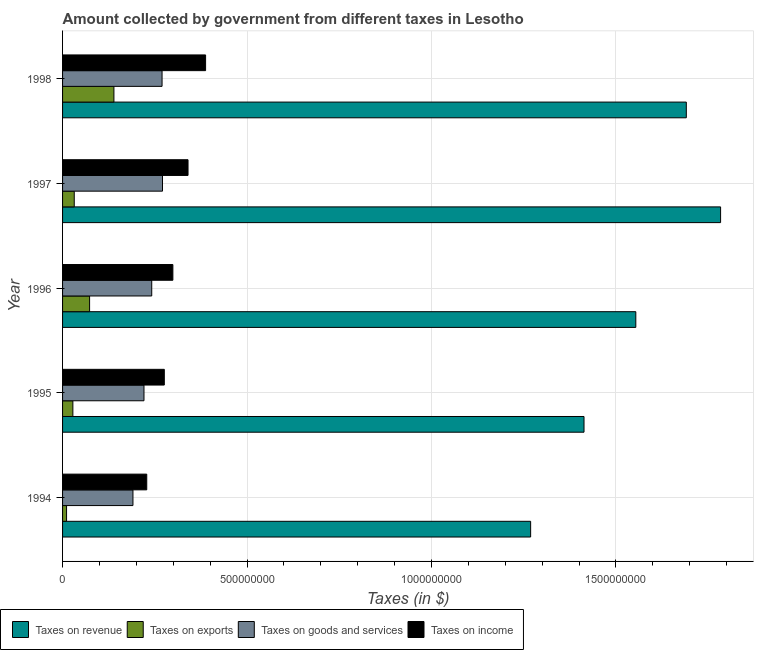How many bars are there on the 2nd tick from the bottom?
Provide a short and direct response. 4. What is the amount collected as tax on revenue in 1995?
Offer a very short reply. 1.41e+09. Across all years, what is the maximum amount collected as tax on income?
Offer a terse response. 3.88e+08. Across all years, what is the minimum amount collected as tax on goods?
Give a very brief answer. 1.91e+08. What is the total amount collected as tax on exports in the graph?
Your answer should be very brief. 2.83e+08. What is the difference between the amount collected as tax on goods in 1994 and that in 1997?
Your answer should be compact. -8.01e+07. What is the difference between the amount collected as tax on exports in 1994 and the amount collected as tax on income in 1995?
Keep it short and to the point. -2.65e+08. What is the average amount collected as tax on income per year?
Offer a very short reply. 3.06e+08. In the year 1996, what is the difference between the amount collected as tax on goods and amount collected as tax on revenue?
Your answer should be compact. -1.31e+09. In how many years, is the amount collected as tax on exports greater than 600000000 $?
Your response must be concise. 0. What is the ratio of the amount collected as tax on income in 1997 to that in 1998?
Your answer should be compact. 0.88. Is the difference between the amount collected as tax on revenue in 1994 and 1996 greater than the difference between the amount collected as tax on goods in 1994 and 1996?
Your response must be concise. No. What is the difference between the highest and the second highest amount collected as tax on goods?
Provide a succinct answer. 1.20e+06. What is the difference between the highest and the lowest amount collected as tax on exports?
Your answer should be very brief. 1.28e+08. Is it the case that in every year, the sum of the amount collected as tax on exports and amount collected as tax on income is greater than the sum of amount collected as tax on goods and amount collected as tax on revenue?
Keep it short and to the point. No. What does the 4th bar from the top in 1997 represents?
Your response must be concise. Taxes on revenue. What does the 3rd bar from the bottom in 1997 represents?
Your answer should be compact. Taxes on goods and services. Is it the case that in every year, the sum of the amount collected as tax on revenue and amount collected as tax on exports is greater than the amount collected as tax on goods?
Provide a succinct answer. Yes. Are all the bars in the graph horizontal?
Offer a very short reply. Yes. What is the difference between two consecutive major ticks on the X-axis?
Your response must be concise. 5.00e+08. Are the values on the major ticks of X-axis written in scientific E-notation?
Provide a short and direct response. No. Does the graph contain any zero values?
Keep it short and to the point. No. Where does the legend appear in the graph?
Your answer should be very brief. Bottom left. How are the legend labels stacked?
Your response must be concise. Horizontal. What is the title of the graph?
Provide a succinct answer. Amount collected by government from different taxes in Lesotho. What is the label or title of the X-axis?
Provide a succinct answer. Taxes (in $). What is the Taxes (in $) in Taxes on revenue in 1994?
Provide a succinct answer. 1.27e+09. What is the Taxes (in $) of Taxes on exports in 1994?
Your answer should be compact. 1.08e+07. What is the Taxes (in $) in Taxes on goods and services in 1994?
Offer a terse response. 1.91e+08. What is the Taxes (in $) in Taxes on income in 1994?
Your answer should be compact. 2.28e+08. What is the Taxes (in $) in Taxes on revenue in 1995?
Your response must be concise. 1.41e+09. What is the Taxes (in $) in Taxes on exports in 1995?
Offer a terse response. 2.79e+07. What is the Taxes (in $) in Taxes on goods and services in 1995?
Offer a very short reply. 2.21e+08. What is the Taxes (in $) in Taxes on income in 1995?
Keep it short and to the point. 2.76e+08. What is the Taxes (in $) in Taxes on revenue in 1996?
Offer a terse response. 1.55e+09. What is the Taxes (in $) of Taxes on exports in 1996?
Give a very brief answer. 7.33e+07. What is the Taxes (in $) in Taxes on goods and services in 1996?
Offer a terse response. 2.42e+08. What is the Taxes (in $) of Taxes on income in 1996?
Your answer should be compact. 2.99e+08. What is the Taxes (in $) of Taxes on revenue in 1997?
Keep it short and to the point. 1.78e+09. What is the Taxes (in $) in Taxes on exports in 1997?
Provide a succinct answer. 3.17e+07. What is the Taxes (in $) in Taxes on goods and services in 1997?
Your response must be concise. 2.71e+08. What is the Taxes (in $) of Taxes on income in 1997?
Offer a very short reply. 3.40e+08. What is the Taxes (in $) of Taxes on revenue in 1998?
Your answer should be very brief. 1.69e+09. What is the Taxes (in $) in Taxes on exports in 1998?
Offer a very short reply. 1.39e+08. What is the Taxes (in $) of Taxes on goods and services in 1998?
Your answer should be very brief. 2.70e+08. What is the Taxes (in $) in Taxes on income in 1998?
Ensure brevity in your answer.  3.88e+08. Across all years, what is the maximum Taxes (in $) of Taxes on revenue?
Ensure brevity in your answer.  1.78e+09. Across all years, what is the maximum Taxes (in $) in Taxes on exports?
Keep it short and to the point. 1.39e+08. Across all years, what is the maximum Taxes (in $) in Taxes on goods and services?
Your answer should be very brief. 2.71e+08. Across all years, what is the maximum Taxes (in $) of Taxes on income?
Provide a succinct answer. 3.88e+08. Across all years, what is the minimum Taxes (in $) in Taxes on revenue?
Your response must be concise. 1.27e+09. Across all years, what is the minimum Taxes (in $) in Taxes on exports?
Offer a very short reply. 1.08e+07. Across all years, what is the minimum Taxes (in $) in Taxes on goods and services?
Provide a succinct answer. 1.91e+08. Across all years, what is the minimum Taxes (in $) of Taxes on income?
Your answer should be very brief. 2.28e+08. What is the total Taxes (in $) of Taxes on revenue in the graph?
Your response must be concise. 7.71e+09. What is the total Taxes (in $) in Taxes on exports in the graph?
Your response must be concise. 2.83e+08. What is the total Taxes (in $) in Taxes on goods and services in the graph?
Give a very brief answer. 1.19e+09. What is the total Taxes (in $) in Taxes on income in the graph?
Make the answer very short. 1.53e+09. What is the difference between the Taxes (in $) in Taxes on revenue in 1994 and that in 1995?
Make the answer very short. -1.45e+08. What is the difference between the Taxes (in $) in Taxes on exports in 1994 and that in 1995?
Provide a succinct answer. -1.71e+07. What is the difference between the Taxes (in $) of Taxes on goods and services in 1994 and that in 1995?
Offer a very short reply. -2.99e+07. What is the difference between the Taxes (in $) of Taxes on income in 1994 and that in 1995?
Provide a succinct answer. -4.76e+07. What is the difference between the Taxes (in $) of Taxes on revenue in 1994 and that in 1996?
Provide a succinct answer. -2.85e+08. What is the difference between the Taxes (in $) in Taxes on exports in 1994 and that in 1996?
Your answer should be compact. -6.24e+07. What is the difference between the Taxes (in $) of Taxes on goods and services in 1994 and that in 1996?
Your answer should be very brief. -5.09e+07. What is the difference between the Taxes (in $) of Taxes on income in 1994 and that in 1996?
Keep it short and to the point. -7.08e+07. What is the difference between the Taxes (in $) of Taxes on revenue in 1994 and that in 1997?
Offer a very short reply. -5.15e+08. What is the difference between the Taxes (in $) of Taxes on exports in 1994 and that in 1997?
Ensure brevity in your answer.  -2.08e+07. What is the difference between the Taxes (in $) in Taxes on goods and services in 1994 and that in 1997?
Offer a very short reply. -8.01e+07. What is the difference between the Taxes (in $) of Taxes on income in 1994 and that in 1997?
Provide a short and direct response. -1.12e+08. What is the difference between the Taxes (in $) in Taxes on revenue in 1994 and that in 1998?
Provide a short and direct response. -4.22e+08. What is the difference between the Taxes (in $) in Taxes on exports in 1994 and that in 1998?
Provide a short and direct response. -1.28e+08. What is the difference between the Taxes (in $) of Taxes on goods and services in 1994 and that in 1998?
Offer a terse response. -7.89e+07. What is the difference between the Taxes (in $) in Taxes on income in 1994 and that in 1998?
Provide a short and direct response. -1.60e+08. What is the difference between the Taxes (in $) in Taxes on revenue in 1995 and that in 1996?
Your answer should be compact. -1.40e+08. What is the difference between the Taxes (in $) of Taxes on exports in 1995 and that in 1996?
Offer a terse response. -4.53e+07. What is the difference between the Taxes (in $) of Taxes on goods and services in 1995 and that in 1996?
Provide a short and direct response. -2.10e+07. What is the difference between the Taxes (in $) in Taxes on income in 1995 and that in 1996?
Provide a succinct answer. -2.32e+07. What is the difference between the Taxes (in $) in Taxes on revenue in 1995 and that in 1997?
Your answer should be very brief. -3.70e+08. What is the difference between the Taxes (in $) in Taxes on exports in 1995 and that in 1997?
Provide a short and direct response. -3.74e+06. What is the difference between the Taxes (in $) in Taxes on goods and services in 1995 and that in 1997?
Offer a very short reply. -5.02e+07. What is the difference between the Taxes (in $) of Taxes on income in 1995 and that in 1997?
Your answer should be very brief. -6.43e+07. What is the difference between the Taxes (in $) in Taxes on revenue in 1995 and that in 1998?
Keep it short and to the point. -2.77e+08. What is the difference between the Taxes (in $) of Taxes on exports in 1995 and that in 1998?
Keep it short and to the point. -1.11e+08. What is the difference between the Taxes (in $) of Taxes on goods and services in 1995 and that in 1998?
Your answer should be compact. -4.90e+07. What is the difference between the Taxes (in $) in Taxes on income in 1995 and that in 1998?
Your response must be concise. -1.12e+08. What is the difference between the Taxes (in $) of Taxes on revenue in 1996 and that in 1997?
Offer a very short reply. -2.30e+08. What is the difference between the Taxes (in $) of Taxes on exports in 1996 and that in 1997?
Your answer should be compact. 4.16e+07. What is the difference between the Taxes (in $) of Taxes on goods and services in 1996 and that in 1997?
Keep it short and to the point. -2.92e+07. What is the difference between the Taxes (in $) of Taxes on income in 1996 and that in 1997?
Give a very brief answer. -4.11e+07. What is the difference between the Taxes (in $) of Taxes on revenue in 1996 and that in 1998?
Keep it short and to the point. -1.37e+08. What is the difference between the Taxes (in $) of Taxes on exports in 1996 and that in 1998?
Your response must be concise. -6.59e+07. What is the difference between the Taxes (in $) of Taxes on goods and services in 1996 and that in 1998?
Your answer should be compact. -2.80e+07. What is the difference between the Taxes (in $) of Taxes on income in 1996 and that in 1998?
Your answer should be compact. -8.87e+07. What is the difference between the Taxes (in $) in Taxes on revenue in 1997 and that in 1998?
Provide a succinct answer. 9.29e+07. What is the difference between the Taxes (in $) of Taxes on exports in 1997 and that in 1998?
Give a very brief answer. -1.08e+08. What is the difference between the Taxes (in $) in Taxes on goods and services in 1997 and that in 1998?
Provide a short and direct response. 1.20e+06. What is the difference between the Taxes (in $) in Taxes on income in 1997 and that in 1998?
Give a very brief answer. -4.76e+07. What is the difference between the Taxes (in $) in Taxes on revenue in 1994 and the Taxes (in $) in Taxes on exports in 1995?
Provide a succinct answer. 1.24e+09. What is the difference between the Taxes (in $) of Taxes on revenue in 1994 and the Taxes (in $) of Taxes on goods and services in 1995?
Provide a succinct answer. 1.05e+09. What is the difference between the Taxes (in $) in Taxes on revenue in 1994 and the Taxes (in $) in Taxes on income in 1995?
Your response must be concise. 9.93e+08. What is the difference between the Taxes (in $) in Taxes on exports in 1994 and the Taxes (in $) in Taxes on goods and services in 1995?
Provide a short and direct response. -2.10e+08. What is the difference between the Taxes (in $) of Taxes on exports in 1994 and the Taxes (in $) of Taxes on income in 1995?
Your response must be concise. -2.65e+08. What is the difference between the Taxes (in $) in Taxes on goods and services in 1994 and the Taxes (in $) in Taxes on income in 1995?
Ensure brevity in your answer.  -8.50e+07. What is the difference between the Taxes (in $) of Taxes on revenue in 1994 and the Taxes (in $) of Taxes on exports in 1996?
Offer a very short reply. 1.20e+09. What is the difference between the Taxes (in $) in Taxes on revenue in 1994 and the Taxes (in $) in Taxes on goods and services in 1996?
Your answer should be very brief. 1.03e+09. What is the difference between the Taxes (in $) of Taxes on revenue in 1994 and the Taxes (in $) of Taxes on income in 1996?
Keep it short and to the point. 9.70e+08. What is the difference between the Taxes (in $) of Taxes on exports in 1994 and the Taxes (in $) of Taxes on goods and services in 1996?
Provide a succinct answer. -2.31e+08. What is the difference between the Taxes (in $) in Taxes on exports in 1994 and the Taxes (in $) in Taxes on income in 1996?
Offer a terse response. -2.88e+08. What is the difference between the Taxes (in $) of Taxes on goods and services in 1994 and the Taxes (in $) of Taxes on income in 1996?
Your answer should be compact. -1.08e+08. What is the difference between the Taxes (in $) in Taxes on revenue in 1994 and the Taxes (in $) in Taxes on exports in 1997?
Provide a succinct answer. 1.24e+09. What is the difference between the Taxes (in $) of Taxes on revenue in 1994 and the Taxes (in $) of Taxes on goods and services in 1997?
Your answer should be very brief. 9.98e+08. What is the difference between the Taxes (in $) in Taxes on revenue in 1994 and the Taxes (in $) in Taxes on income in 1997?
Keep it short and to the point. 9.29e+08. What is the difference between the Taxes (in $) in Taxes on exports in 1994 and the Taxes (in $) in Taxes on goods and services in 1997?
Ensure brevity in your answer.  -2.60e+08. What is the difference between the Taxes (in $) of Taxes on exports in 1994 and the Taxes (in $) of Taxes on income in 1997?
Give a very brief answer. -3.29e+08. What is the difference between the Taxes (in $) in Taxes on goods and services in 1994 and the Taxes (in $) in Taxes on income in 1997?
Keep it short and to the point. -1.49e+08. What is the difference between the Taxes (in $) of Taxes on revenue in 1994 and the Taxes (in $) of Taxes on exports in 1998?
Offer a very short reply. 1.13e+09. What is the difference between the Taxes (in $) in Taxes on revenue in 1994 and the Taxes (in $) in Taxes on goods and services in 1998?
Keep it short and to the point. 9.99e+08. What is the difference between the Taxes (in $) of Taxes on revenue in 1994 and the Taxes (in $) of Taxes on income in 1998?
Provide a succinct answer. 8.81e+08. What is the difference between the Taxes (in $) of Taxes on exports in 1994 and the Taxes (in $) of Taxes on goods and services in 1998?
Give a very brief answer. -2.59e+08. What is the difference between the Taxes (in $) in Taxes on exports in 1994 and the Taxes (in $) in Taxes on income in 1998?
Offer a very short reply. -3.77e+08. What is the difference between the Taxes (in $) in Taxes on goods and services in 1994 and the Taxes (in $) in Taxes on income in 1998?
Provide a succinct answer. -1.97e+08. What is the difference between the Taxes (in $) in Taxes on revenue in 1995 and the Taxes (in $) in Taxes on exports in 1996?
Your answer should be very brief. 1.34e+09. What is the difference between the Taxes (in $) of Taxes on revenue in 1995 and the Taxes (in $) of Taxes on goods and services in 1996?
Ensure brevity in your answer.  1.17e+09. What is the difference between the Taxes (in $) of Taxes on revenue in 1995 and the Taxes (in $) of Taxes on income in 1996?
Keep it short and to the point. 1.11e+09. What is the difference between the Taxes (in $) in Taxes on exports in 1995 and the Taxes (in $) in Taxes on goods and services in 1996?
Give a very brief answer. -2.14e+08. What is the difference between the Taxes (in $) of Taxes on exports in 1995 and the Taxes (in $) of Taxes on income in 1996?
Provide a succinct answer. -2.71e+08. What is the difference between the Taxes (in $) of Taxes on goods and services in 1995 and the Taxes (in $) of Taxes on income in 1996?
Your response must be concise. -7.83e+07. What is the difference between the Taxes (in $) of Taxes on revenue in 1995 and the Taxes (in $) of Taxes on exports in 1997?
Provide a succinct answer. 1.38e+09. What is the difference between the Taxes (in $) in Taxes on revenue in 1995 and the Taxes (in $) in Taxes on goods and services in 1997?
Give a very brief answer. 1.14e+09. What is the difference between the Taxes (in $) in Taxes on revenue in 1995 and the Taxes (in $) in Taxes on income in 1997?
Your answer should be compact. 1.07e+09. What is the difference between the Taxes (in $) in Taxes on exports in 1995 and the Taxes (in $) in Taxes on goods and services in 1997?
Your answer should be compact. -2.43e+08. What is the difference between the Taxes (in $) of Taxes on exports in 1995 and the Taxes (in $) of Taxes on income in 1997?
Your response must be concise. -3.12e+08. What is the difference between the Taxes (in $) of Taxes on goods and services in 1995 and the Taxes (in $) of Taxes on income in 1997?
Give a very brief answer. -1.19e+08. What is the difference between the Taxes (in $) in Taxes on revenue in 1995 and the Taxes (in $) in Taxes on exports in 1998?
Keep it short and to the point. 1.27e+09. What is the difference between the Taxes (in $) in Taxes on revenue in 1995 and the Taxes (in $) in Taxes on goods and services in 1998?
Offer a terse response. 1.14e+09. What is the difference between the Taxes (in $) in Taxes on revenue in 1995 and the Taxes (in $) in Taxes on income in 1998?
Make the answer very short. 1.03e+09. What is the difference between the Taxes (in $) in Taxes on exports in 1995 and the Taxes (in $) in Taxes on goods and services in 1998?
Your answer should be compact. -2.42e+08. What is the difference between the Taxes (in $) of Taxes on exports in 1995 and the Taxes (in $) of Taxes on income in 1998?
Ensure brevity in your answer.  -3.60e+08. What is the difference between the Taxes (in $) of Taxes on goods and services in 1995 and the Taxes (in $) of Taxes on income in 1998?
Provide a succinct answer. -1.67e+08. What is the difference between the Taxes (in $) in Taxes on revenue in 1996 and the Taxes (in $) in Taxes on exports in 1997?
Provide a short and direct response. 1.52e+09. What is the difference between the Taxes (in $) in Taxes on revenue in 1996 and the Taxes (in $) in Taxes on goods and services in 1997?
Give a very brief answer. 1.28e+09. What is the difference between the Taxes (in $) of Taxes on revenue in 1996 and the Taxes (in $) of Taxes on income in 1997?
Keep it short and to the point. 1.21e+09. What is the difference between the Taxes (in $) in Taxes on exports in 1996 and the Taxes (in $) in Taxes on goods and services in 1997?
Provide a short and direct response. -1.98e+08. What is the difference between the Taxes (in $) in Taxes on exports in 1996 and the Taxes (in $) in Taxes on income in 1997?
Your answer should be compact. -2.67e+08. What is the difference between the Taxes (in $) in Taxes on goods and services in 1996 and the Taxes (in $) in Taxes on income in 1997?
Your answer should be very brief. -9.84e+07. What is the difference between the Taxes (in $) in Taxes on revenue in 1996 and the Taxes (in $) in Taxes on exports in 1998?
Your answer should be compact. 1.41e+09. What is the difference between the Taxes (in $) in Taxes on revenue in 1996 and the Taxes (in $) in Taxes on goods and services in 1998?
Provide a succinct answer. 1.28e+09. What is the difference between the Taxes (in $) in Taxes on revenue in 1996 and the Taxes (in $) in Taxes on income in 1998?
Your answer should be very brief. 1.17e+09. What is the difference between the Taxes (in $) of Taxes on exports in 1996 and the Taxes (in $) of Taxes on goods and services in 1998?
Give a very brief answer. -1.96e+08. What is the difference between the Taxes (in $) of Taxes on exports in 1996 and the Taxes (in $) of Taxes on income in 1998?
Give a very brief answer. -3.14e+08. What is the difference between the Taxes (in $) of Taxes on goods and services in 1996 and the Taxes (in $) of Taxes on income in 1998?
Keep it short and to the point. -1.46e+08. What is the difference between the Taxes (in $) in Taxes on revenue in 1997 and the Taxes (in $) in Taxes on exports in 1998?
Give a very brief answer. 1.64e+09. What is the difference between the Taxes (in $) of Taxes on revenue in 1997 and the Taxes (in $) of Taxes on goods and services in 1998?
Your response must be concise. 1.51e+09. What is the difference between the Taxes (in $) in Taxes on revenue in 1997 and the Taxes (in $) in Taxes on income in 1998?
Ensure brevity in your answer.  1.40e+09. What is the difference between the Taxes (in $) of Taxes on exports in 1997 and the Taxes (in $) of Taxes on goods and services in 1998?
Keep it short and to the point. -2.38e+08. What is the difference between the Taxes (in $) of Taxes on exports in 1997 and the Taxes (in $) of Taxes on income in 1998?
Keep it short and to the point. -3.56e+08. What is the difference between the Taxes (in $) in Taxes on goods and services in 1997 and the Taxes (in $) in Taxes on income in 1998?
Your answer should be compact. -1.17e+08. What is the average Taxes (in $) in Taxes on revenue per year?
Give a very brief answer. 1.54e+09. What is the average Taxes (in $) of Taxes on exports per year?
Provide a short and direct response. 5.66e+07. What is the average Taxes (in $) in Taxes on goods and services per year?
Your response must be concise. 2.39e+08. What is the average Taxes (in $) of Taxes on income per year?
Offer a terse response. 3.06e+08. In the year 1994, what is the difference between the Taxes (in $) in Taxes on revenue and Taxes (in $) in Taxes on exports?
Offer a terse response. 1.26e+09. In the year 1994, what is the difference between the Taxes (in $) of Taxes on revenue and Taxes (in $) of Taxes on goods and services?
Your response must be concise. 1.08e+09. In the year 1994, what is the difference between the Taxes (in $) in Taxes on revenue and Taxes (in $) in Taxes on income?
Ensure brevity in your answer.  1.04e+09. In the year 1994, what is the difference between the Taxes (in $) in Taxes on exports and Taxes (in $) in Taxes on goods and services?
Ensure brevity in your answer.  -1.80e+08. In the year 1994, what is the difference between the Taxes (in $) of Taxes on exports and Taxes (in $) of Taxes on income?
Your answer should be very brief. -2.17e+08. In the year 1994, what is the difference between the Taxes (in $) in Taxes on goods and services and Taxes (in $) in Taxes on income?
Offer a terse response. -3.74e+07. In the year 1995, what is the difference between the Taxes (in $) of Taxes on revenue and Taxes (in $) of Taxes on exports?
Keep it short and to the point. 1.39e+09. In the year 1995, what is the difference between the Taxes (in $) in Taxes on revenue and Taxes (in $) in Taxes on goods and services?
Your response must be concise. 1.19e+09. In the year 1995, what is the difference between the Taxes (in $) in Taxes on revenue and Taxes (in $) in Taxes on income?
Give a very brief answer. 1.14e+09. In the year 1995, what is the difference between the Taxes (in $) of Taxes on exports and Taxes (in $) of Taxes on goods and services?
Provide a succinct answer. -1.93e+08. In the year 1995, what is the difference between the Taxes (in $) in Taxes on exports and Taxes (in $) in Taxes on income?
Give a very brief answer. -2.48e+08. In the year 1995, what is the difference between the Taxes (in $) in Taxes on goods and services and Taxes (in $) in Taxes on income?
Offer a terse response. -5.51e+07. In the year 1996, what is the difference between the Taxes (in $) of Taxes on revenue and Taxes (in $) of Taxes on exports?
Make the answer very short. 1.48e+09. In the year 1996, what is the difference between the Taxes (in $) in Taxes on revenue and Taxes (in $) in Taxes on goods and services?
Your answer should be compact. 1.31e+09. In the year 1996, what is the difference between the Taxes (in $) in Taxes on revenue and Taxes (in $) in Taxes on income?
Offer a very short reply. 1.25e+09. In the year 1996, what is the difference between the Taxes (in $) in Taxes on exports and Taxes (in $) in Taxes on goods and services?
Give a very brief answer. -1.68e+08. In the year 1996, what is the difference between the Taxes (in $) of Taxes on exports and Taxes (in $) of Taxes on income?
Offer a very short reply. -2.26e+08. In the year 1996, what is the difference between the Taxes (in $) of Taxes on goods and services and Taxes (in $) of Taxes on income?
Offer a terse response. -5.73e+07. In the year 1997, what is the difference between the Taxes (in $) of Taxes on revenue and Taxes (in $) of Taxes on exports?
Ensure brevity in your answer.  1.75e+09. In the year 1997, what is the difference between the Taxes (in $) in Taxes on revenue and Taxes (in $) in Taxes on goods and services?
Your response must be concise. 1.51e+09. In the year 1997, what is the difference between the Taxes (in $) of Taxes on revenue and Taxes (in $) of Taxes on income?
Your answer should be compact. 1.44e+09. In the year 1997, what is the difference between the Taxes (in $) of Taxes on exports and Taxes (in $) of Taxes on goods and services?
Your answer should be very brief. -2.39e+08. In the year 1997, what is the difference between the Taxes (in $) in Taxes on exports and Taxes (in $) in Taxes on income?
Provide a short and direct response. -3.08e+08. In the year 1997, what is the difference between the Taxes (in $) of Taxes on goods and services and Taxes (in $) of Taxes on income?
Offer a terse response. -6.92e+07. In the year 1998, what is the difference between the Taxes (in $) of Taxes on revenue and Taxes (in $) of Taxes on exports?
Provide a short and direct response. 1.55e+09. In the year 1998, what is the difference between the Taxes (in $) in Taxes on revenue and Taxes (in $) in Taxes on goods and services?
Offer a terse response. 1.42e+09. In the year 1998, what is the difference between the Taxes (in $) in Taxes on revenue and Taxes (in $) in Taxes on income?
Provide a succinct answer. 1.30e+09. In the year 1998, what is the difference between the Taxes (in $) in Taxes on exports and Taxes (in $) in Taxes on goods and services?
Offer a very short reply. -1.30e+08. In the year 1998, what is the difference between the Taxes (in $) of Taxes on exports and Taxes (in $) of Taxes on income?
Offer a terse response. -2.48e+08. In the year 1998, what is the difference between the Taxes (in $) in Taxes on goods and services and Taxes (in $) in Taxes on income?
Your response must be concise. -1.18e+08. What is the ratio of the Taxes (in $) in Taxes on revenue in 1994 to that in 1995?
Your answer should be very brief. 0.9. What is the ratio of the Taxes (in $) in Taxes on exports in 1994 to that in 1995?
Ensure brevity in your answer.  0.39. What is the ratio of the Taxes (in $) in Taxes on goods and services in 1994 to that in 1995?
Your answer should be very brief. 0.86. What is the ratio of the Taxes (in $) in Taxes on income in 1994 to that in 1995?
Your answer should be compact. 0.83. What is the ratio of the Taxes (in $) of Taxes on revenue in 1994 to that in 1996?
Keep it short and to the point. 0.82. What is the ratio of the Taxes (in $) of Taxes on exports in 1994 to that in 1996?
Make the answer very short. 0.15. What is the ratio of the Taxes (in $) in Taxes on goods and services in 1994 to that in 1996?
Offer a very short reply. 0.79. What is the ratio of the Taxes (in $) of Taxes on income in 1994 to that in 1996?
Provide a short and direct response. 0.76. What is the ratio of the Taxes (in $) in Taxes on revenue in 1994 to that in 1997?
Offer a terse response. 0.71. What is the ratio of the Taxes (in $) in Taxes on exports in 1994 to that in 1997?
Give a very brief answer. 0.34. What is the ratio of the Taxes (in $) of Taxes on goods and services in 1994 to that in 1997?
Provide a short and direct response. 0.7. What is the ratio of the Taxes (in $) of Taxes on income in 1994 to that in 1997?
Ensure brevity in your answer.  0.67. What is the ratio of the Taxes (in $) in Taxes on revenue in 1994 to that in 1998?
Offer a very short reply. 0.75. What is the ratio of the Taxes (in $) of Taxes on exports in 1994 to that in 1998?
Make the answer very short. 0.08. What is the ratio of the Taxes (in $) in Taxes on goods and services in 1994 to that in 1998?
Keep it short and to the point. 0.71. What is the ratio of the Taxes (in $) of Taxes on income in 1994 to that in 1998?
Your answer should be compact. 0.59. What is the ratio of the Taxes (in $) in Taxes on revenue in 1995 to that in 1996?
Your answer should be very brief. 0.91. What is the ratio of the Taxes (in $) in Taxes on exports in 1995 to that in 1996?
Your response must be concise. 0.38. What is the ratio of the Taxes (in $) in Taxes on goods and services in 1995 to that in 1996?
Provide a succinct answer. 0.91. What is the ratio of the Taxes (in $) in Taxes on income in 1995 to that in 1996?
Offer a terse response. 0.92. What is the ratio of the Taxes (in $) of Taxes on revenue in 1995 to that in 1997?
Offer a very short reply. 0.79. What is the ratio of the Taxes (in $) in Taxes on exports in 1995 to that in 1997?
Your answer should be very brief. 0.88. What is the ratio of the Taxes (in $) of Taxes on goods and services in 1995 to that in 1997?
Give a very brief answer. 0.81. What is the ratio of the Taxes (in $) in Taxes on income in 1995 to that in 1997?
Provide a succinct answer. 0.81. What is the ratio of the Taxes (in $) of Taxes on revenue in 1995 to that in 1998?
Offer a very short reply. 0.84. What is the ratio of the Taxes (in $) of Taxes on exports in 1995 to that in 1998?
Give a very brief answer. 0.2. What is the ratio of the Taxes (in $) of Taxes on goods and services in 1995 to that in 1998?
Your answer should be very brief. 0.82. What is the ratio of the Taxes (in $) in Taxes on income in 1995 to that in 1998?
Provide a succinct answer. 0.71. What is the ratio of the Taxes (in $) of Taxes on revenue in 1996 to that in 1997?
Keep it short and to the point. 0.87. What is the ratio of the Taxes (in $) in Taxes on exports in 1996 to that in 1997?
Make the answer very short. 2.31. What is the ratio of the Taxes (in $) of Taxes on goods and services in 1996 to that in 1997?
Provide a succinct answer. 0.89. What is the ratio of the Taxes (in $) of Taxes on income in 1996 to that in 1997?
Your answer should be very brief. 0.88. What is the ratio of the Taxes (in $) of Taxes on revenue in 1996 to that in 1998?
Provide a short and direct response. 0.92. What is the ratio of the Taxes (in $) in Taxes on exports in 1996 to that in 1998?
Provide a succinct answer. 0.53. What is the ratio of the Taxes (in $) in Taxes on goods and services in 1996 to that in 1998?
Provide a short and direct response. 0.9. What is the ratio of the Taxes (in $) of Taxes on income in 1996 to that in 1998?
Your answer should be very brief. 0.77. What is the ratio of the Taxes (in $) of Taxes on revenue in 1997 to that in 1998?
Your answer should be compact. 1.05. What is the ratio of the Taxes (in $) of Taxes on exports in 1997 to that in 1998?
Keep it short and to the point. 0.23. What is the ratio of the Taxes (in $) in Taxes on income in 1997 to that in 1998?
Provide a short and direct response. 0.88. What is the difference between the highest and the second highest Taxes (in $) in Taxes on revenue?
Ensure brevity in your answer.  9.29e+07. What is the difference between the highest and the second highest Taxes (in $) of Taxes on exports?
Your answer should be very brief. 6.59e+07. What is the difference between the highest and the second highest Taxes (in $) in Taxes on goods and services?
Keep it short and to the point. 1.20e+06. What is the difference between the highest and the second highest Taxes (in $) of Taxes on income?
Offer a very short reply. 4.76e+07. What is the difference between the highest and the lowest Taxes (in $) of Taxes on revenue?
Provide a short and direct response. 5.15e+08. What is the difference between the highest and the lowest Taxes (in $) in Taxes on exports?
Keep it short and to the point. 1.28e+08. What is the difference between the highest and the lowest Taxes (in $) in Taxes on goods and services?
Your answer should be compact. 8.01e+07. What is the difference between the highest and the lowest Taxes (in $) of Taxes on income?
Make the answer very short. 1.60e+08. 